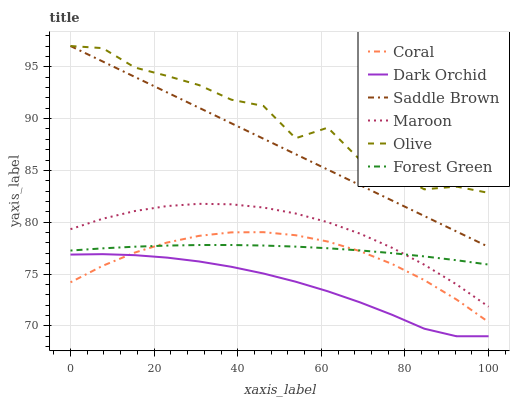Does Dark Orchid have the minimum area under the curve?
Answer yes or no. Yes. Does Olive have the maximum area under the curve?
Answer yes or no. Yes. Does Maroon have the minimum area under the curve?
Answer yes or no. No. Does Maroon have the maximum area under the curve?
Answer yes or no. No. Is Saddle Brown the smoothest?
Answer yes or no. Yes. Is Olive the roughest?
Answer yes or no. Yes. Is Maroon the smoothest?
Answer yes or no. No. Is Maroon the roughest?
Answer yes or no. No. Does Dark Orchid have the lowest value?
Answer yes or no. Yes. Does Maroon have the lowest value?
Answer yes or no. No. Does Saddle Brown have the highest value?
Answer yes or no. Yes. Does Maroon have the highest value?
Answer yes or no. No. Is Dark Orchid less than Olive?
Answer yes or no. Yes. Is Olive greater than Coral?
Answer yes or no. Yes. Does Forest Green intersect Maroon?
Answer yes or no. Yes. Is Forest Green less than Maroon?
Answer yes or no. No. Is Forest Green greater than Maroon?
Answer yes or no. No. Does Dark Orchid intersect Olive?
Answer yes or no. No. 